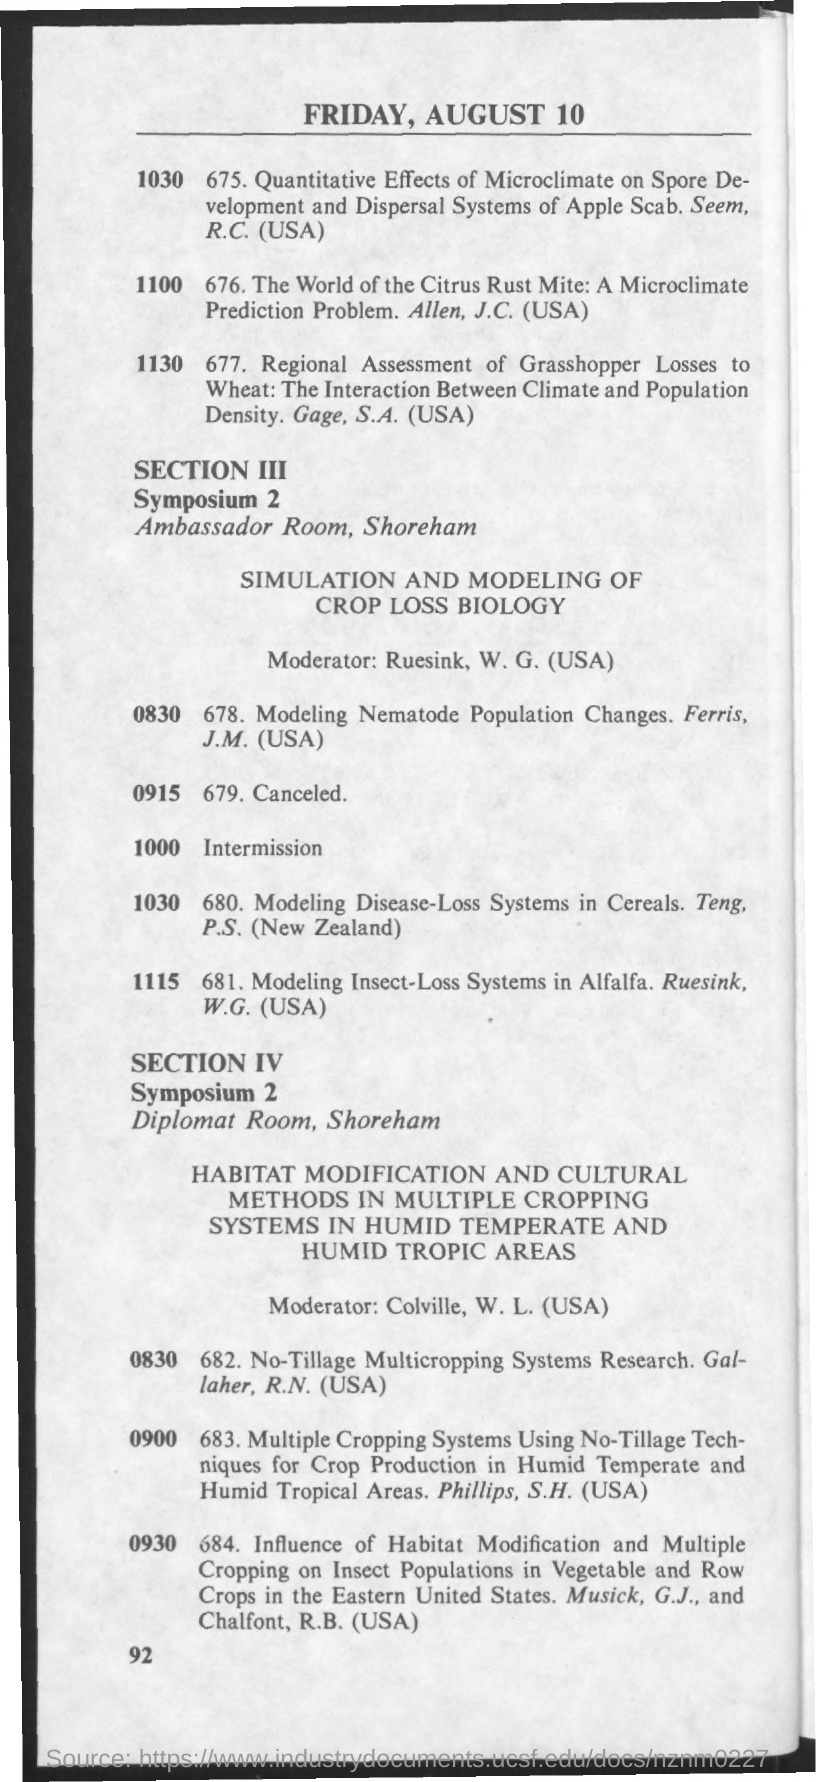Mention a couple of crucial points in this snapshot. The date mentioned in the given page is Friday, August 10. The Ambasador Room is the name of the room for Symposium 2, Section 3. The moderator mentioned in section 4 is Colville, W.L. (USA). The room designated for Symposium 2, Section 4 is known as the Diplomat Room. The moderator mentioned in section 3 is RUESINK, W.G. (USA). 